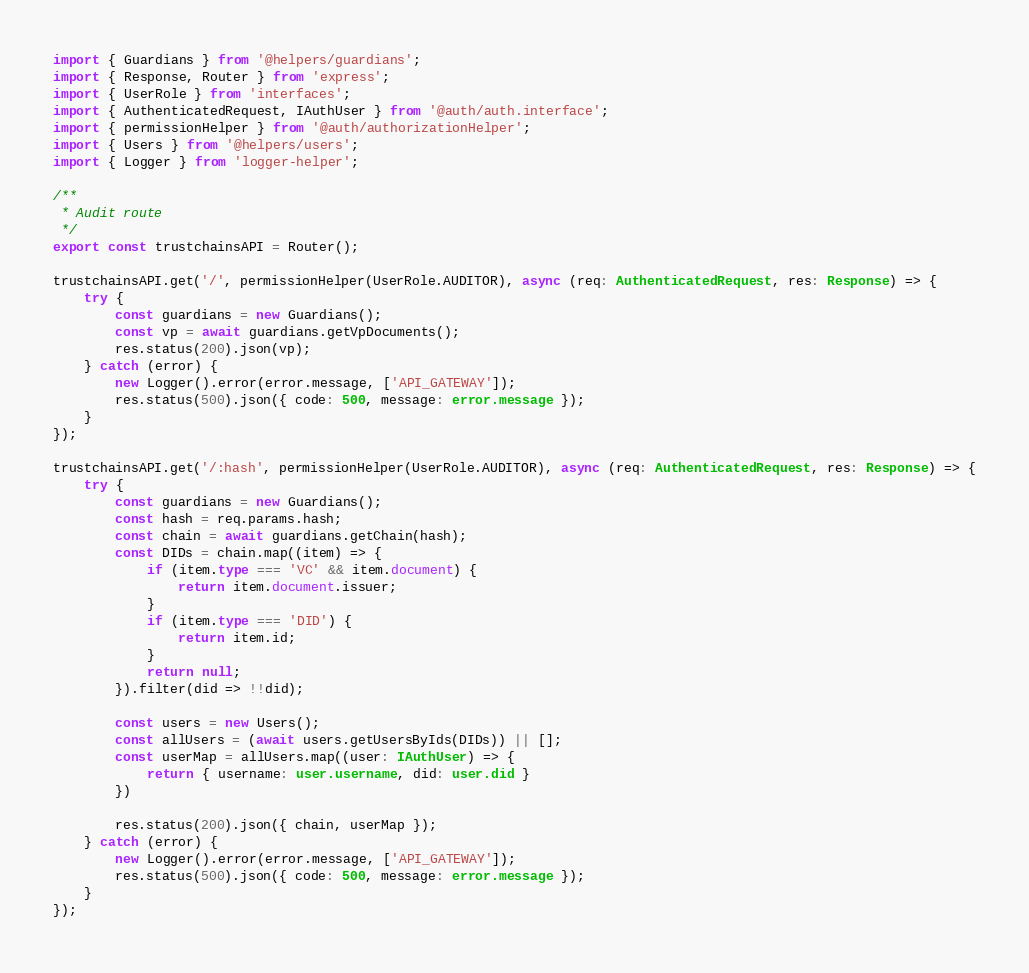Convert code to text. <code><loc_0><loc_0><loc_500><loc_500><_TypeScript_>import { Guardians } from '@helpers/guardians';
import { Response, Router } from 'express';
import { UserRole } from 'interfaces';
import { AuthenticatedRequest, IAuthUser } from '@auth/auth.interface';
import { permissionHelper } from '@auth/authorizationHelper';
import { Users } from '@helpers/users';
import { Logger } from 'logger-helper';

/**
 * Audit route
 */
export const trustchainsAPI = Router();

trustchainsAPI.get('/', permissionHelper(UserRole.AUDITOR), async (req: AuthenticatedRequest, res: Response) => {
    try {
        const guardians = new Guardians();
        const vp = await guardians.getVpDocuments();
        res.status(200).json(vp);
    } catch (error) {
        new Logger().error(error.message, ['API_GATEWAY']);
        res.status(500).json({ code: 500, message: error.message });
    }
});

trustchainsAPI.get('/:hash', permissionHelper(UserRole.AUDITOR), async (req: AuthenticatedRequest, res: Response) => {
    try {
        const guardians = new Guardians();
        const hash = req.params.hash;
        const chain = await guardians.getChain(hash);
        const DIDs = chain.map((item) => {
            if (item.type === 'VC' && item.document) {
                return item.document.issuer;
            }
            if (item.type === 'DID') {
                return item.id;
            }
            return null;
        }).filter(did => !!did);

        const users = new Users();
        const allUsers = (await users.getUsersByIds(DIDs)) || [];
        const userMap = allUsers.map((user: IAuthUser) => {
            return { username: user.username, did: user.did }
        })

        res.status(200).json({ chain, userMap });
    } catch (error) {
        new Logger().error(error.message, ['API_GATEWAY']);
        res.status(500).json({ code: 500, message: error.message });
    }
});
</code> 